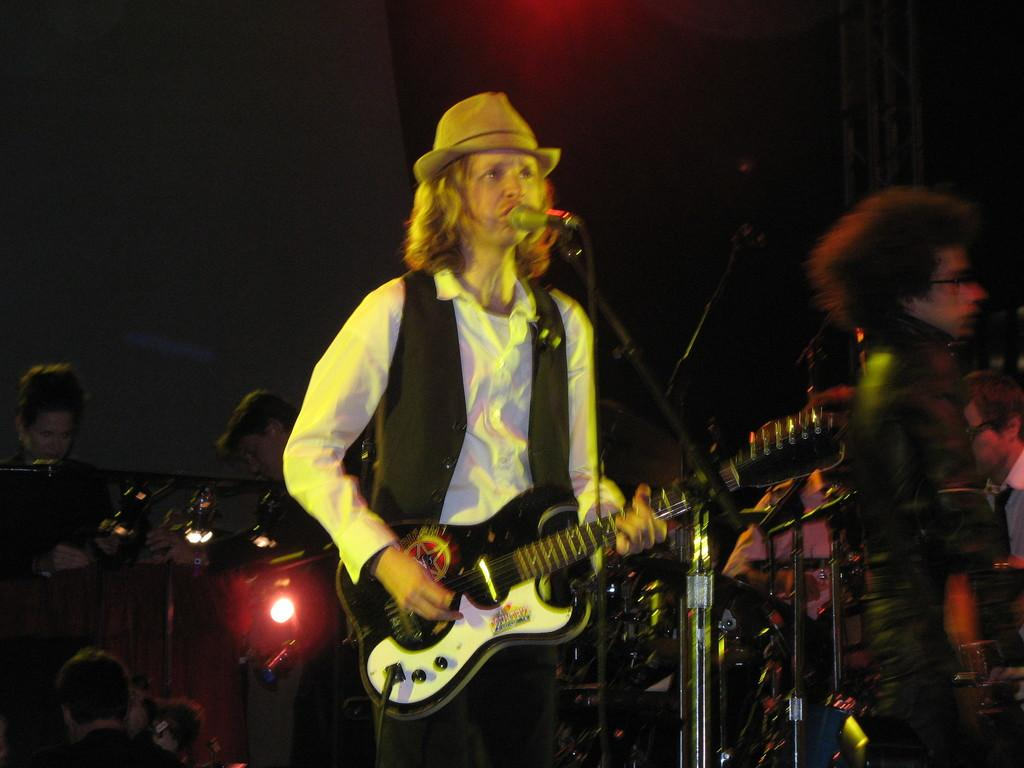How many people are in the image? There are multiple persons in the image. Can you describe the position of the person in the front? The person in the front is standing. What is the person in the front doing? The person in the front is singing. What objects is the person in the front holding? The person in the front is holding a microphone and a guitar. Are there any plants visible in the image? There is no mention of plants in the provided facts, so we cannot determine if any are present in the image. 